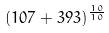<formula> <loc_0><loc_0><loc_500><loc_500>( 1 0 7 + 3 9 3 ) ^ { \frac { 1 0 } { 1 0 } }</formula> 